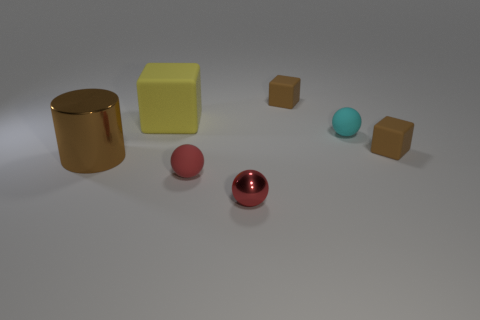What number of yellow matte blocks are behind the big matte cube?
Your answer should be compact. 0. Are there any big yellow cubes made of the same material as the small cyan thing?
Provide a succinct answer. Yes. Are there more things in front of the big yellow cube than big rubber things that are right of the red metallic sphere?
Provide a succinct answer. Yes. What is the size of the shiny sphere?
Make the answer very short. Small. What is the shape of the tiny brown object that is behind the large yellow block?
Give a very brief answer. Cube. Is the small cyan thing the same shape as the tiny metallic object?
Provide a succinct answer. Yes. Is the number of tiny matte balls behind the red rubber sphere the same as the number of tiny red matte spheres?
Provide a succinct answer. Yes. What shape is the red shiny object?
Your answer should be very brief. Sphere. Is there anything else of the same color as the large metallic cylinder?
Your response must be concise. Yes. Do the brown cube that is in front of the small cyan matte ball and the cylinder left of the tiny cyan matte ball have the same size?
Your response must be concise. No. 